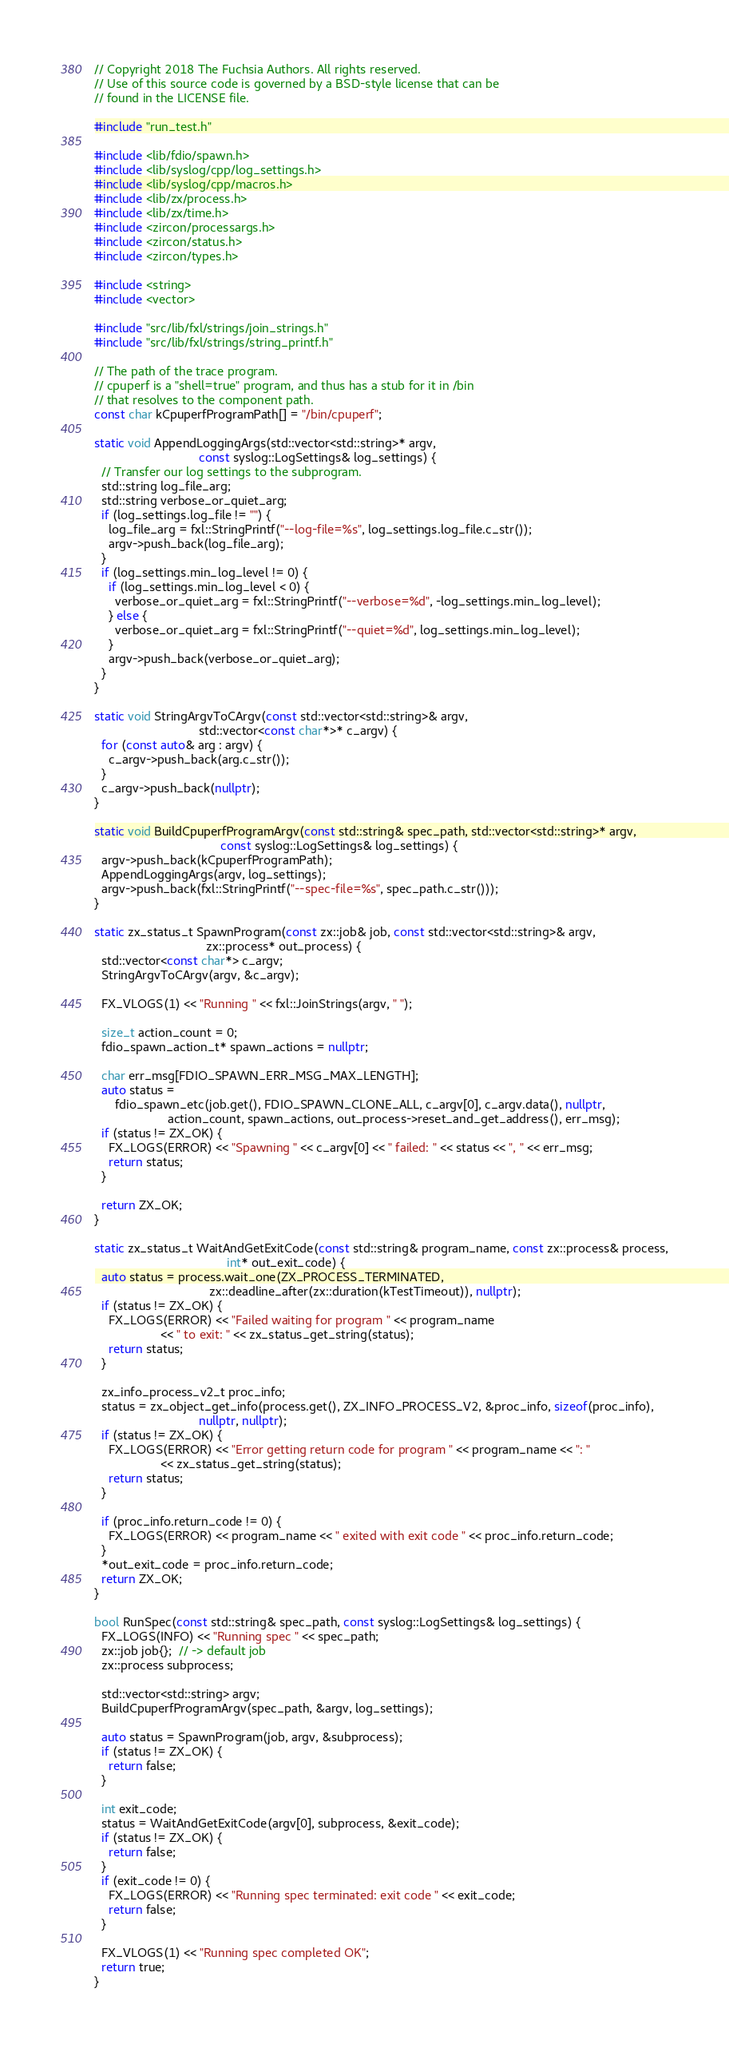<code> <loc_0><loc_0><loc_500><loc_500><_C++_>// Copyright 2018 The Fuchsia Authors. All rights reserved.
// Use of this source code is governed by a BSD-style license that can be
// found in the LICENSE file.

#include "run_test.h"

#include <lib/fdio/spawn.h>
#include <lib/syslog/cpp/log_settings.h>
#include <lib/syslog/cpp/macros.h>
#include <lib/zx/process.h>
#include <lib/zx/time.h>
#include <zircon/processargs.h>
#include <zircon/status.h>
#include <zircon/types.h>

#include <string>
#include <vector>

#include "src/lib/fxl/strings/join_strings.h"
#include "src/lib/fxl/strings/string_printf.h"

// The path of the trace program.
// cpuperf is a "shell=true" program, and thus has a stub for it in /bin
// that resolves to the component path.
const char kCpuperfProgramPath[] = "/bin/cpuperf";

static void AppendLoggingArgs(std::vector<std::string>* argv,
                              const syslog::LogSettings& log_settings) {
  // Transfer our log settings to the subprogram.
  std::string log_file_arg;
  std::string verbose_or_quiet_arg;
  if (log_settings.log_file != "") {
    log_file_arg = fxl::StringPrintf("--log-file=%s", log_settings.log_file.c_str());
    argv->push_back(log_file_arg);
  }
  if (log_settings.min_log_level != 0) {
    if (log_settings.min_log_level < 0) {
      verbose_or_quiet_arg = fxl::StringPrintf("--verbose=%d", -log_settings.min_log_level);
    } else {
      verbose_or_quiet_arg = fxl::StringPrintf("--quiet=%d", log_settings.min_log_level);
    }
    argv->push_back(verbose_or_quiet_arg);
  }
}

static void StringArgvToCArgv(const std::vector<std::string>& argv,
                              std::vector<const char*>* c_argv) {
  for (const auto& arg : argv) {
    c_argv->push_back(arg.c_str());
  }
  c_argv->push_back(nullptr);
}

static void BuildCpuperfProgramArgv(const std::string& spec_path, std::vector<std::string>* argv,
                                    const syslog::LogSettings& log_settings) {
  argv->push_back(kCpuperfProgramPath);
  AppendLoggingArgs(argv, log_settings);
  argv->push_back(fxl::StringPrintf("--spec-file=%s", spec_path.c_str()));
}

static zx_status_t SpawnProgram(const zx::job& job, const std::vector<std::string>& argv,
                                zx::process* out_process) {
  std::vector<const char*> c_argv;
  StringArgvToCArgv(argv, &c_argv);

  FX_VLOGS(1) << "Running " << fxl::JoinStrings(argv, " ");

  size_t action_count = 0;
  fdio_spawn_action_t* spawn_actions = nullptr;

  char err_msg[FDIO_SPAWN_ERR_MSG_MAX_LENGTH];
  auto status =
      fdio_spawn_etc(job.get(), FDIO_SPAWN_CLONE_ALL, c_argv[0], c_argv.data(), nullptr,
                     action_count, spawn_actions, out_process->reset_and_get_address(), err_msg);
  if (status != ZX_OK) {
    FX_LOGS(ERROR) << "Spawning " << c_argv[0] << " failed: " << status << ", " << err_msg;
    return status;
  }

  return ZX_OK;
}

static zx_status_t WaitAndGetExitCode(const std::string& program_name, const zx::process& process,
                                      int* out_exit_code) {
  auto status = process.wait_one(ZX_PROCESS_TERMINATED,
                                 zx::deadline_after(zx::duration(kTestTimeout)), nullptr);
  if (status != ZX_OK) {
    FX_LOGS(ERROR) << "Failed waiting for program " << program_name
                   << " to exit: " << zx_status_get_string(status);
    return status;
  }

  zx_info_process_v2_t proc_info;
  status = zx_object_get_info(process.get(), ZX_INFO_PROCESS_V2, &proc_info, sizeof(proc_info),
                              nullptr, nullptr);
  if (status != ZX_OK) {
    FX_LOGS(ERROR) << "Error getting return code for program " << program_name << ": "
                   << zx_status_get_string(status);
    return status;
  }

  if (proc_info.return_code != 0) {
    FX_LOGS(ERROR) << program_name << " exited with exit code " << proc_info.return_code;
  }
  *out_exit_code = proc_info.return_code;
  return ZX_OK;
}

bool RunSpec(const std::string& spec_path, const syslog::LogSettings& log_settings) {
  FX_LOGS(INFO) << "Running spec " << spec_path;
  zx::job job{};  // -> default job
  zx::process subprocess;

  std::vector<std::string> argv;
  BuildCpuperfProgramArgv(spec_path, &argv, log_settings);

  auto status = SpawnProgram(job, argv, &subprocess);
  if (status != ZX_OK) {
    return false;
  }

  int exit_code;
  status = WaitAndGetExitCode(argv[0], subprocess, &exit_code);
  if (status != ZX_OK) {
    return false;
  }
  if (exit_code != 0) {
    FX_LOGS(ERROR) << "Running spec terminated: exit code " << exit_code;
    return false;
  }

  FX_VLOGS(1) << "Running spec completed OK";
  return true;
}
</code> 